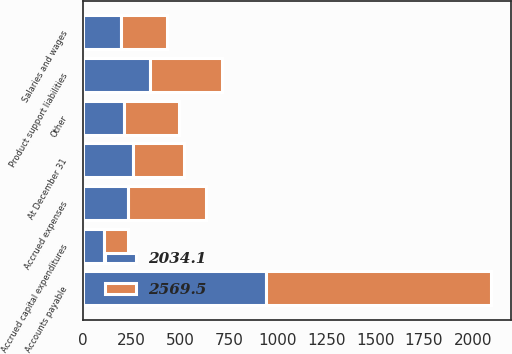Convert chart to OTSL. <chart><loc_0><loc_0><loc_500><loc_500><stacked_bar_chart><ecel><fcel>At December 31<fcel>Accounts payable<fcel>Product support liabilities<fcel>Accrued expenses<fcel>Accrued capital expenditures<fcel>Salaries and wages<fcel>Other<nl><fcel>2569.5<fcel>260.6<fcel>1154.7<fcel>372.1<fcel>401.4<fcel>120.1<fcel>238.9<fcel>282.3<nl><fcel>2034.1<fcel>260.6<fcel>938.6<fcel>344.2<fcel>233.1<fcel>111.2<fcel>194.8<fcel>212.2<nl></chart> 